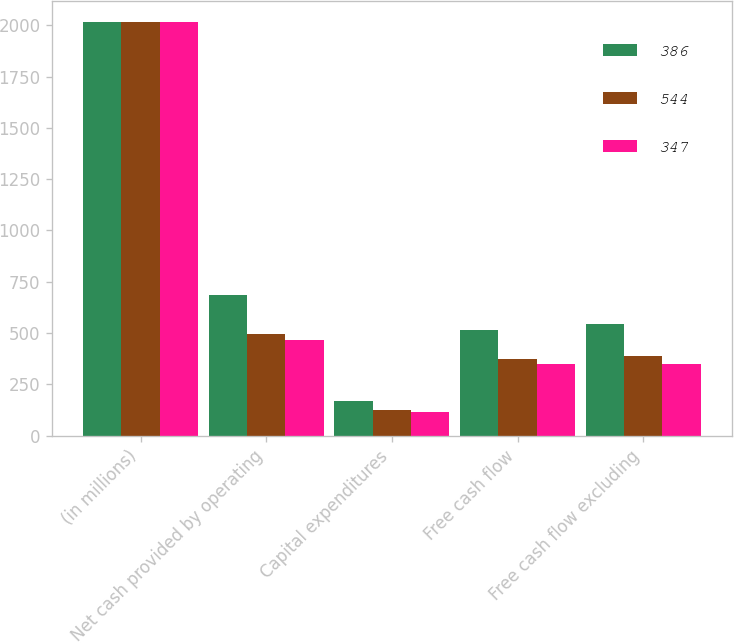Convert chart to OTSL. <chart><loc_0><loc_0><loc_500><loc_500><stacked_bar_chart><ecel><fcel>(in millions)<fcel>Net cash provided by operating<fcel>Capital expenditures<fcel>Free cash flow<fcel>Free cash flow excluding<nl><fcel>386<fcel>2017<fcel>686<fcel>170<fcel>516<fcel>544<nl><fcel>544<fcel>2016<fcel>497<fcel>124<fcel>373<fcel>386<nl><fcel>347<fcel>2015<fcel>464<fcel>117<fcel>347<fcel>347<nl></chart> 